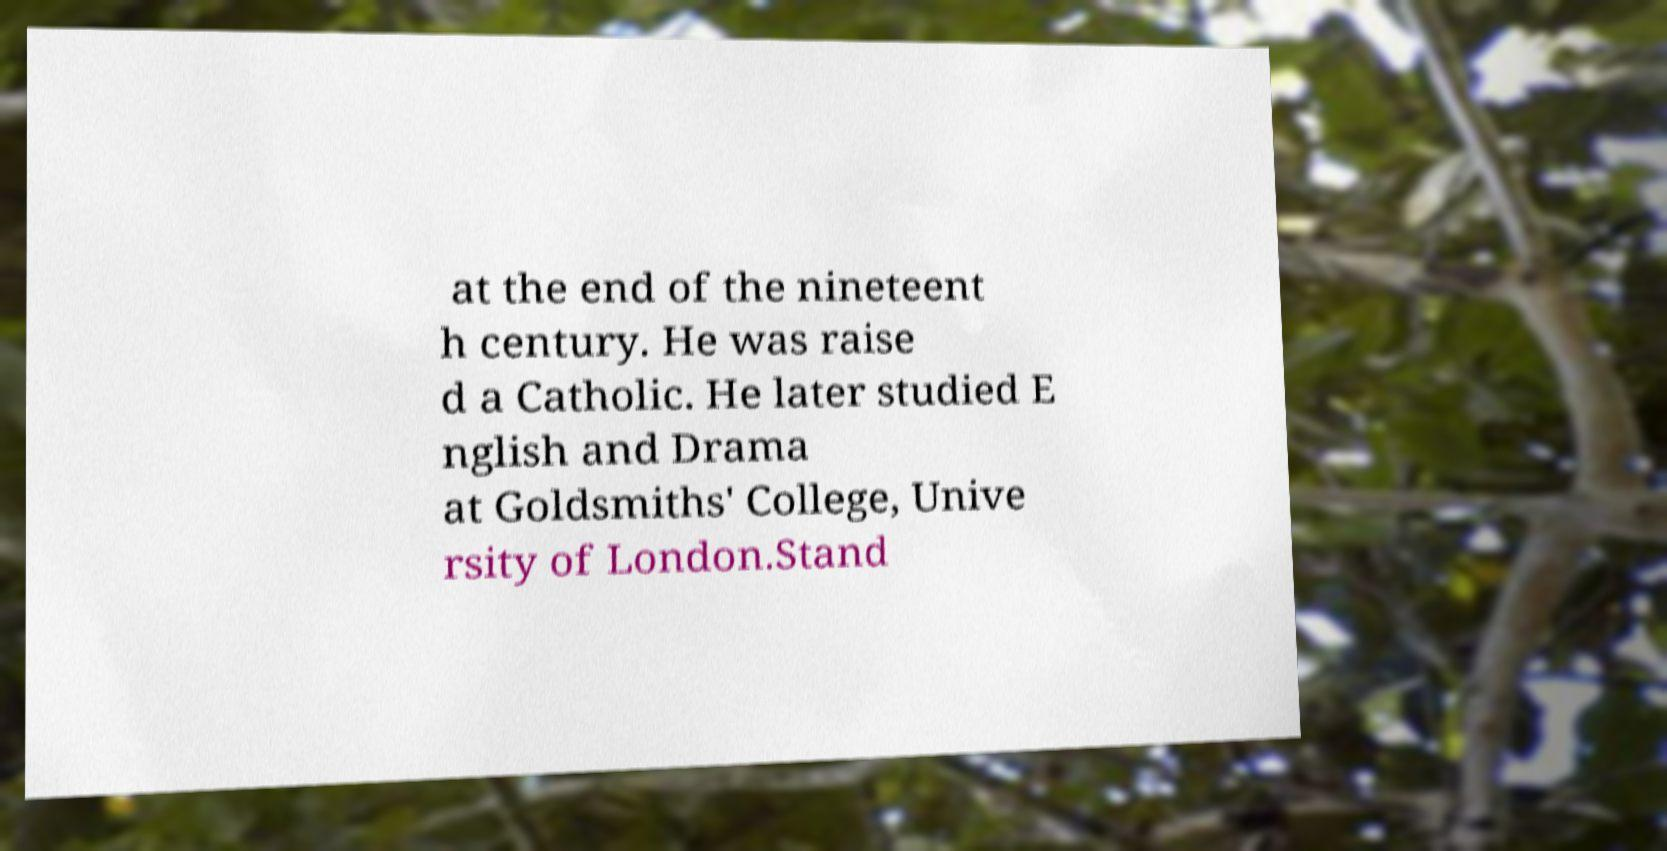What messages or text are displayed in this image? I need them in a readable, typed format. at the end of the nineteent h century. He was raise d a Catholic. He later studied E nglish and Drama at Goldsmiths' College, Unive rsity of London.Stand 